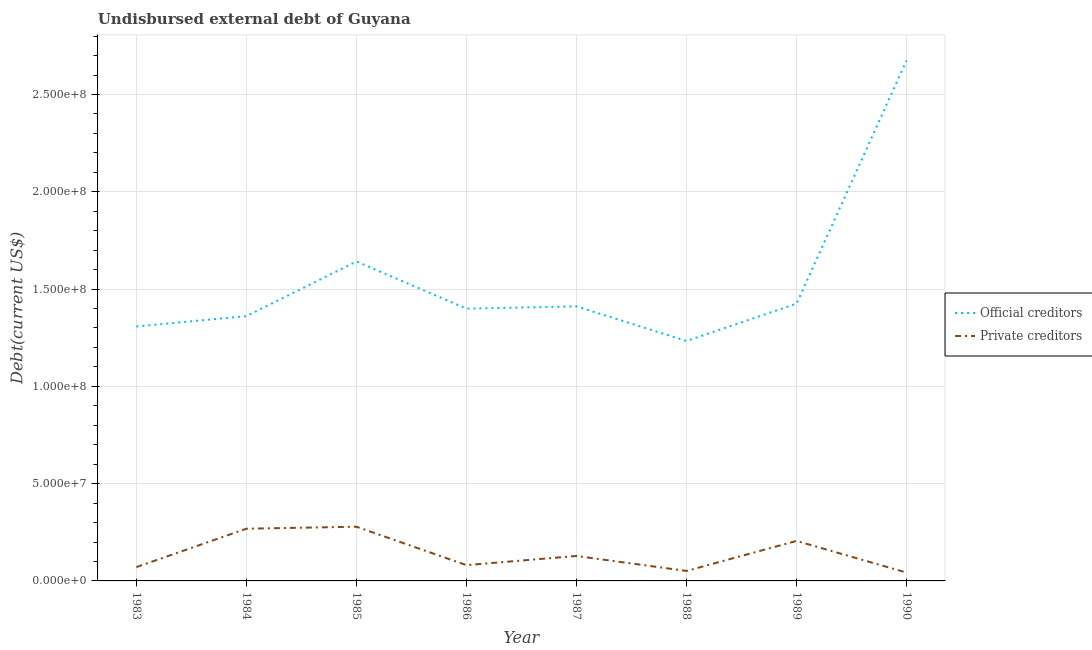How many different coloured lines are there?
Ensure brevity in your answer.  2. Is the number of lines equal to the number of legend labels?
Provide a short and direct response. Yes. What is the undisbursed external debt of private creditors in 1987?
Keep it short and to the point. 1.28e+07. Across all years, what is the maximum undisbursed external debt of official creditors?
Give a very brief answer. 2.67e+08. Across all years, what is the minimum undisbursed external debt of private creditors?
Offer a terse response. 4.30e+06. In which year was the undisbursed external debt of official creditors minimum?
Ensure brevity in your answer.  1988. What is the total undisbursed external debt of official creditors in the graph?
Give a very brief answer. 1.25e+09. What is the difference between the undisbursed external debt of official creditors in 1984 and that in 1990?
Make the answer very short. -1.31e+08. What is the difference between the undisbursed external debt of official creditors in 1987 and the undisbursed external debt of private creditors in 1984?
Make the answer very short. 1.14e+08. What is the average undisbursed external debt of official creditors per year?
Your response must be concise. 1.56e+08. In the year 1986, what is the difference between the undisbursed external debt of official creditors and undisbursed external debt of private creditors?
Your answer should be compact. 1.32e+08. In how many years, is the undisbursed external debt of official creditors greater than 110000000 US$?
Ensure brevity in your answer.  8. What is the ratio of the undisbursed external debt of private creditors in 1986 to that in 1988?
Provide a short and direct response. 1.58. Is the undisbursed external debt of private creditors in 1983 less than that in 1984?
Provide a succinct answer. Yes. Is the difference between the undisbursed external debt of official creditors in 1983 and 1984 greater than the difference between the undisbursed external debt of private creditors in 1983 and 1984?
Offer a very short reply. Yes. What is the difference between the highest and the second highest undisbursed external debt of private creditors?
Your answer should be compact. 1.03e+06. What is the difference between the highest and the lowest undisbursed external debt of official creditors?
Your response must be concise. 1.44e+08. Is the sum of the undisbursed external debt of official creditors in 1983 and 1986 greater than the maximum undisbursed external debt of private creditors across all years?
Your answer should be compact. Yes. Is the undisbursed external debt of private creditors strictly less than the undisbursed external debt of official creditors over the years?
Provide a short and direct response. Yes. How many lines are there?
Provide a short and direct response. 2. How many years are there in the graph?
Provide a succinct answer. 8. What is the difference between two consecutive major ticks on the Y-axis?
Provide a short and direct response. 5.00e+07. Does the graph contain any zero values?
Provide a short and direct response. No. Does the graph contain grids?
Ensure brevity in your answer.  Yes. What is the title of the graph?
Give a very brief answer. Undisbursed external debt of Guyana. Does "Public funds" appear as one of the legend labels in the graph?
Provide a succinct answer. No. What is the label or title of the X-axis?
Your response must be concise. Year. What is the label or title of the Y-axis?
Offer a very short reply. Debt(current US$). What is the Debt(current US$) in Official creditors in 1983?
Keep it short and to the point. 1.31e+08. What is the Debt(current US$) in Private creditors in 1983?
Your answer should be compact. 7.11e+06. What is the Debt(current US$) in Official creditors in 1984?
Your answer should be very brief. 1.36e+08. What is the Debt(current US$) of Private creditors in 1984?
Your response must be concise. 2.68e+07. What is the Debt(current US$) of Official creditors in 1985?
Offer a terse response. 1.64e+08. What is the Debt(current US$) of Private creditors in 1985?
Keep it short and to the point. 2.79e+07. What is the Debt(current US$) of Official creditors in 1986?
Provide a short and direct response. 1.40e+08. What is the Debt(current US$) in Private creditors in 1986?
Your answer should be very brief. 8.12e+06. What is the Debt(current US$) in Official creditors in 1987?
Provide a short and direct response. 1.41e+08. What is the Debt(current US$) of Private creditors in 1987?
Your answer should be very brief. 1.28e+07. What is the Debt(current US$) in Official creditors in 1988?
Offer a terse response. 1.23e+08. What is the Debt(current US$) in Private creditors in 1988?
Offer a very short reply. 5.13e+06. What is the Debt(current US$) of Official creditors in 1989?
Give a very brief answer. 1.42e+08. What is the Debt(current US$) in Private creditors in 1989?
Your answer should be very brief. 2.06e+07. What is the Debt(current US$) of Official creditors in 1990?
Provide a short and direct response. 2.67e+08. What is the Debt(current US$) in Private creditors in 1990?
Your answer should be compact. 4.30e+06. Across all years, what is the maximum Debt(current US$) of Official creditors?
Your response must be concise. 2.67e+08. Across all years, what is the maximum Debt(current US$) in Private creditors?
Keep it short and to the point. 2.79e+07. Across all years, what is the minimum Debt(current US$) of Official creditors?
Your answer should be compact. 1.23e+08. Across all years, what is the minimum Debt(current US$) in Private creditors?
Make the answer very short. 4.30e+06. What is the total Debt(current US$) in Official creditors in the graph?
Give a very brief answer. 1.25e+09. What is the total Debt(current US$) of Private creditors in the graph?
Provide a short and direct response. 1.13e+08. What is the difference between the Debt(current US$) in Official creditors in 1983 and that in 1984?
Offer a very short reply. -5.34e+06. What is the difference between the Debt(current US$) in Private creditors in 1983 and that in 1984?
Your response must be concise. -1.97e+07. What is the difference between the Debt(current US$) of Official creditors in 1983 and that in 1985?
Give a very brief answer. -3.34e+07. What is the difference between the Debt(current US$) in Private creditors in 1983 and that in 1985?
Give a very brief answer. -2.08e+07. What is the difference between the Debt(current US$) in Official creditors in 1983 and that in 1986?
Give a very brief answer. -9.17e+06. What is the difference between the Debt(current US$) of Private creditors in 1983 and that in 1986?
Provide a succinct answer. -1.01e+06. What is the difference between the Debt(current US$) in Official creditors in 1983 and that in 1987?
Make the answer very short. -1.03e+07. What is the difference between the Debt(current US$) of Private creditors in 1983 and that in 1987?
Your answer should be very brief. -5.71e+06. What is the difference between the Debt(current US$) in Official creditors in 1983 and that in 1988?
Offer a terse response. 7.45e+06. What is the difference between the Debt(current US$) of Private creditors in 1983 and that in 1988?
Ensure brevity in your answer.  1.98e+06. What is the difference between the Debt(current US$) in Official creditors in 1983 and that in 1989?
Make the answer very short. -1.17e+07. What is the difference between the Debt(current US$) of Private creditors in 1983 and that in 1989?
Make the answer very short. -1.34e+07. What is the difference between the Debt(current US$) of Official creditors in 1983 and that in 1990?
Your answer should be compact. -1.37e+08. What is the difference between the Debt(current US$) in Private creditors in 1983 and that in 1990?
Your response must be concise. 2.81e+06. What is the difference between the Debt(current US$) of Official creditors in 1984 and that in 1985?
Offer a terse response. -2.81e+07. What is the difference between the Debt(current US$) in Private creditors in 1984 and that in 1985?
Ensure brevity in your answer.  -1.03e+06. What is the difference between the Debt(current US$) in Official creditors in 1984 and that in 1986?
Your response must be concise. -3.84e+06. What is the difference between the Debt(current US$) in Private creditors in 1984 and that in 1986?
Your answer should be compact. 1.87e+07. What is the difference between the Debt(current US$) in Official creditors in 1984 and that in 1987?
Keep it short and to the point. -4.99e+06. What is the difference between the Debt(current US$) in Private creditors in 1984 and that in 1987?
Your answer should be very brief. 1.40e+07. What is the difference between the Debt(current US$) in Official creditors in 1984 and that in 1988?
Ensure brevity in your answer.  1.28e+07. What is the difference between the Debt(current US$) in Private creditors in 1984 and that in 1988?
Offer a very short reply. 2.17e+07. What is the difference between the Debt(current US$) of Official creditors in 1984 and that in 1989?
Give a very brief answer. -6.39e+06. What is the difference between the Debt(current US$) of Private creditors in 1984 and that in 1989?
Ensure brevity in your answer.  6.28e+06. What is the difference between the Debt(current US$) of Official creditors in 1984 and that in 1990?
Give a very brief answer. -1.31e+08. What is the difference between the Debt(current US$) of Private creditors in 1984 and that in 1990?
Your response must be concise. 2.25e+07. What is the difference between the Debt(current US$) of Official creditors in 1985 and that in 1986?
Ensure brevity in your answer.  2.42e+07. What is the difference between the Debt(current US$) of Private creditors in 1985 and that in 1986?
Provide a succinct answer. 1.97e+07. What is the difference between the Debt(current US$) of Official creditors in 1985 and that in 1987?
Give a very brief answer. 2.31e+07. What is the difference between the Debt(current US$) of Private creditors in 1985 and that in 1987?
Provide a succinct answer. 1.50e+07. What is the difference between the Debt(current US$) in Official creditors in 1985 and that in 1988?
Ensure brevity in your answer.  4.09e+07. What is the difference between the Debt(current US$) of Private creditors in 1985 and that in 1988?
Offer a terse response. 2.27e+07. What is the difference between the Debt(current US$) of Official creditors in 1985 and that in 1989?
Keep it short and to the point. 2.17e+07. What is the difference between the Debt(current US$) in Private creditors in 1985 and that in 1989?
Give a very brief answer. 7.31e+06. What is the difference between the Debt(current US$) of Official creditors in 1985 and that in 1990?
Provide a succinct answer. -1.03e+08. What is the difference between the Debt(current US$) of Private creditors in 1985 and that in 1990?
Give a very brief answer. 2.36e+07. What is the difference between the Debt(current US$) in Official creditors in 1986 and that in 1987?
Your answer should be compact. -1.16e+06. What is the difference between the Debt(current US$) in Private creditors in 1986 and that in 1987?
Provide a succinct answer. -4.70e+06. What is the difference between the Debt(current US$) of Official creditors in 1986 and that in 1988?
Keep it short and to the point. 1.66e+07. What is the difference between the Debt(current US$) in Private creditors in 1986 and that in 1988?
Give a very brief answer. 2.99e+06. What is the difference between the Debt(current US$) of Official creditors in 1986 and that in 1989?
Ensure brevity in your answer.  -2.56e+06. What is the difference between the Debt(current US$) in Private creditors in 1986 and that in 1989?
Provide a succinct answer. -1.24e+07. What is the difference between the Debt(current US$) in Official creditors in 1986 and that in 1990?
Give a very brief answer. -1.28e+08. What is the difference between the Debt(current US$) of Private creditors in 1986 and that in 1990?
Provide a short and direct response. 3.82e+06. What is the difference between the Debt(current US$) of Official creditors in 1987 and that in 1988?
Your response must be concise. 1.78e+07. What is the difference between the Debt(current US$) of Private creditors in 1987 and that in 1988?
Your answer should be compact. 7.69e+06. What is the difference between the Debt(current US$) of Official creditors in 1987 and that in 1989?
Your answer should be compact. -1.40e+06. What is the difference between the Debt(current US$) of Private creditors in 1987 and that in 1989?
Your response must be concise. -7.73e+06. What is the difference between the Debt(current US$) of Official creditors in 1987 and that in 1990?
Your response must be concise. -1.26e+08. What is the difference between the Debt(current US$) in Private creditors in 1987 and that in 1990?
Offer a terse response. 8.52e+06. What is the difference between the Debt(current US$) of Official creditors in 1988 and that in 1989?
Provide a succinct answer. -1.92e+07. What is the difference between the Debt(current US$) in Private creditors in 1988 and that in 1989?
Your answer should be compact. -1.54e+07. What is the difference between the Debt(current US$) of Official creditors in 1988 and that in 1990?
Your answer should be compact. -1.44e+08. What is the difference between the Debt(current US$) of Private creditors in 1988 and that in 1990?
Your answer should be very brief. 8.28e+05. What is the difference between the Debt(current US$) in Official creditors in 1989 and that in 1990?
Your answer should be compact. -1.25e+08. What is the difference between the Debt(current US$) of Private creditors in 1989 and that in 1990?
Your response must be concise. 1.62e+07. What is the difference between the Debt(current US$) in Official creditors in 1983 and the Debt(current US$) in Private creditors in 1984?
Provide a short and direct response. 1.04e+08. What is the difference between the Debt(current US$) in Official creditors in 1983 and the Debt(current US$) in Private creditors in 1985?
Provide a short and direct response. 1.03e+08. What is the difference between the Debt(current US$) of Official creditors in 1983 and the Debt(current US$) of Private creditors in 1986?
Your answer should be very brief. 1.23e+08. What is the difference between the Debt(current US$) in Official creditors in 1983 and the Debt(current US$) in Private creditors in 1987?
Your answer should be very brief. 1.18e+08. What is the difference between the Debt(current US$) in Official creditors in 1983 and the Debt(current US$) in Private creditors in 1988?
Ensure brevity in your answer.  1.26e+08. What is the difference between the Debt(current US$) in Official creditors in 1983 and the Debt(current US$) in Private creditors in 1989?
Ensure brevity in your answer.  1.10e+08. What is the difference between the Debt(current US$) in Official creditors in 1983 and the Debt(current US$) in Private creditors in 1990?
Provide a succinct answer. 1.26e+08. What is the difference between the Debt(current US$) of Official creditors in 1984 and the Debt(current US$) of Private creditors in 1985?
Provide a succinct answer. 1.08e+08. What is the difference between the Debt(current US$) of Official creditors in 1984 and the Debt(current US$) of Private creditors in 1986?
Offer a terse response. 1.28e+08. What is the difference between the Debt(current US$) of Official creditors in 1984 and the Debt(current US$) of Private creditors in 1987?
Provide a succinct answer. 1.23e+08. What is the difference between the Debt(current US$) in Official creditors in 1984 and the Debt(current US$) in Private creditors in 1988?
Give a very brief answer. 1.31e+08. What is the difference between the Debt(current US$) of Official creditors in 1984 and the Debt(current US$) of Private creditors in 1989?
Your response must be concise. 1.16e+08. What is the difference between the Debt(current US$) of Official creditors in 1984 and the Debt(current US$) of Private creditors in 1990?
Your answer should be very brief. 1.32e+08. What is the difference between the Debt(current US$) of Official creditors in 1985 and the Debt(current US$) of Private creditors in 1986?
Ensure brevity in your answer.  1.56e+08. What is the difference between the Debt(current US$) in Official creditors in 1985 and the Debt(current US$) in Private creditors in 1987?
Ensure brevity in your answer.  1.51e+08. What is the difference between the Debt(current US$) in Official creditors in 1985 and the Debt(current US$) in Private creditors in 1988?
Make the answer very short. 1.59e+08. What is the difference between the Debt(current US$) in Official creditors in 1985 and the Debt(current US$) in Private creditors in 1989?
Make the answer very short. 1.44e+08. What is the difference between the Debt(current US$) of Official creditors in 1985 and the Debt(current US$) of Private creditors in 1990?
Your answer should be compact. 1.60e+08. What is the difference between the Debt(current US$) in Official creditors in 1986 and the Debt(current US$) in Private creditors in 1987?
Your answer should be very brief. 1.27e+08. What is the difference between the Debt(current US$) in Official creditors in 1986 and the Debt(current US$) in Private creditors in 1988?
Ensure brevity in your answer.  1.35e+08. What is the difference between the Debt(current US$) of Official creditors in 1986 and the Debt(current US$) of Private creditors in 1989?
Your answer should be very brief. 1.19e+08. What is the difference between the Debt(current US$) in Official creditors in 1986 and the Debt(current US$) in Private creditors in 1990?
Keep it short and to the point. 1.36e+08. What is the difference between the Debt(current US$) of Official creditors in 1987 and the Debt(current US$) of Private creditors in 1988?
Make the answer very short. 1.36e+08. What is the difference between the Debt(current US$) in Official creditors in 1987 and the Debt(current US$) in Private creditors in 1989?
Keep it short and to the point. 1.21e+08. What is the difference between the Debt(current US$) of Official creditors in 1987 and the Debt(current US$) of Private creditors in 1990?
Offer a very short reply. 1.37e+08. What is the difference between the Debt(current US$) in Official creditors in 1988 and the Debt(current US$) in Private creditors in 1989?
Offer a terse response. 1.03e+08. What is the difference between the Debt(current US$) in Official creditors in 1988 and the Debt(current US$) in Private creditors in 1990?
Keep it short and to the point. 1.19e+08. What is the difference between the Debt(current US$) of Official creditors in 1989 and the Debt(current US$) of Private creditors in 1990?
Ensure brevity in your answer.  1.38e+08. What is the average Debt(current US$) of Official creditors per year?
Provide a succinct answer. 1.56e+08. What is the average Debt(current US$) in Private creditors per year?
Offer a very short reply. 1.41e+07. In the year 1983, what is the difference between the Debt(current US$) in Official creditors and Debt(current US$) in Private creditors?
Your response must be concise. 1.24e+08. In the year 1984, what is the difference between the Debt(current US$) in Official creditors and Debt(current US$) in Private creditors?
Ensure brevity in your answer.  1.09e+08. In the year 1985, what is the difference between the Debt(current US$) of Official creditors and Debt(current US$) of Private creditors?
Provide a succinct answer. 1.36e+08. In the year 1986, what is the difference between the Debt(current US$) in Official creditors and Debt(current US$) in Private creditors?
Your answer should be compact. 1.32e+08. In the year 1987, what is the difference between the Debt(current US$) in Official creditors and Debt(current US$) in Private creditors?
Ensure brevity in your answer.  1.28e+08. In the year 1988, what is the difference between the Debt(current US$) of Official creditors and Debt(current US$) of Private creditors?
Your response must be concise. 1.18e+08. In the year 1989, what is the difference between the Debt(current US$) of Official creditors and Debt(current US$) of Private creditors?
Provide a short and direct response. 1.22e+08. In the year 1990, what is the difference between the Debt(current US$) in Official creditors and Debt(current US$) in Private creditors?
Provide a short and direct response. 2.63e+08. What is the ratio of the Debt(current US$) in Official creditors in 1983 to that in 1984?
Your answer should be very brief. 0.96. What is the ratio of the Debt(current US$) of Private creditors in 1983 to that in 1984?
Give a very brief answer. 0.26. What is the ratio of the Debt(current US$) of Official creditors in 1983 to that in 1985?
Give a very brief answer. 0.8. What is the ratio of the Debt(current US$) in Private creditors in 1983 to that in 1985?
Provide a succinct answer. 0.26. What is the ratio of the Debt(current US$) in Official creditors in 1983 to that in 1986?
Keep it short and to the point. 0.93. What is the ratio of the Debt(current US$) in Private creditors in 1983 to that in 1986?
Your response must be concise. 0.88. What is the ratio of the Debt(current US$) of Official creditors in 1983 to that in 1987?
Ensure brevity in your answer.  0.93. What is the ratio of the Debt(current US$) of Private creditors in 1983 to that in 1987?
Offer a terse response. 0.55. What is the ratio of the Debt(current US$) of Official creditors in 1983 to that in 1988?
Offer a terse response. 1.06. What is the ratio of the Debt(current US$) of Private creditors in 1983 to that in 1988?
Make the answer very short. 1.39. What is the ratio of the Debt(current US$) of Official creditors in 1983 to that in 1989?
Ensure brevity in your answer.  0.92. What is the ratio of the Debt(current US$) of Private creditors in 1983 to that in 1989?
Your response must be concise. 0.35. What is the ratio of the Debt(current US$) in Official creditors in 1983 to that in 1990?
Your answer should be compact. 0.49. What is the ratio of the Debt(current US$) in Private creditors in 1983 to that in 1990?
Provide a succinct answer. 1.65. What is the ratio of the Debt(current US$) in Official creditors in 1984 to that in 1985?
Keep it short and to the point. 0.83. What is the ratio of the Debt(current US$) of Private creditors in 1984 to that in 1985?
Your answer should be compact. 0.96. What is the ratio of the Debt(current US$) of Official creditors in 1984 to that in 1986?
Keep it short and to the point. 0.97. What is the ratio of the Debt(current US$) in Private creditors in 1984 to that in 1986?
Your answer should be compact. 3.31. What is the ratio of the Debt(current US$) of Official creditors in 1984 to that in 1987?
Provide a succinct answer. 0.96. What is the ratio of the Debt(current US$) of Private creditors in 1984 to that in 1987?
Your response must be concise. 2.09. What is the ratio of the Debt(current US$) of Official creditors in 1984 to that in 1988?
Offer a very short reply. 1.1. What is the ratio of the Debt(current US$) in Private creditors in 1984 to that in 1988?
Your answer should be very brief. 5.23. What is the ratio of the Debt(current US$) in Official creditors in 1984 to that in 1989?
Ensure brevity in your answer.  0.96. What is the ratio of the Debt(current US$) in Private creditors in 1984 to that in 1989?
Give a very brief answer. 1.31. What is the ratio of the Debt(current US$) of Official creditors in 1984 to that in 1990?
Your answer should be very brief. 0.51. What is the ratio of the Debt(current US$) in Private creditors in 1984 to that in 1990?
Provide a short and direct response. 6.24. What is the ratio of the Debt(current US$) of Official creditors in 1985 to that in 1986?
Offer a very short reply. 1.17. What is the ratio of the Debt(current US$) of Private creditors in 1985 to that in 1986?
Offer a terse response. 3.43. What is the ratio of the Debt(current US$) in Official creditors in 1985 to that in 1987?
Your answer should be very brief. 1.16. What is the ratio of the Debt(current US$) in Private creditors in 1985 to that in 1987?
Your answer should be compact. 2.17. What is the ratio of the Debt(current US$) in Official creditors in 1985 to that in 1988?
Your answer should be very brief. 1.33. What is the ratio of the Debt(current US$) of Private creditors in 1985 to that in 1988?
Provide a short and direct response. 5.43. What is the ratio of the Debt(current US$) in Official creditors in 1985 to that in 1989?
Offer a terse response. 1.15. What is the ratio of the Debt(current US$) of Private creditors in 1985 to that in 1989?
Your answer should be very brief. 1.36. What is the ratio of the Debt(current US$) in Official creditors in 1985 to that in 1990?
Ensure brevity in your answer.  0.61. What is the ratio of the Debt(current US$) in Private creditors in 1985 to that in 1990?
Keep it short and to the point. 6.48. What is the ratio of the Debt(current US$) in Official creditors in 1986 to that in 1987?
Provide a succinct answer. 0.99. What is the ratio of the Debt(current US$) in Private creditors in 1986 to that in 1987?
Offer a very short reply. 0.63. What is the ratio of the Debt(current US$) of Official creditors in 1986 to that in 1988?
Offer a terse response. 1.13. What is the ratio of the Debt(current US$) in Private creditors in 1986 to that in 1988?
Make the answer very short. 1.58. What is the ratio of the Debt(current US$) of Official creditors in 1986 to that in 1989?
Give a very brief answer. 0.98. What is the ratio of the Debt(current US$) in Private creditors in 1986 to that in 1989?
Ensure brevity in your answer.  0.39. What is the ratio of the Debt(current US$) in Official creditors in 1986 to that in 1990?
Keep it short and to the point. 0.52. What is the ratio of the Debt(current US$) in Private creditors in 1986 to that in 1990?
Give a very brief answer. 1.89. What is the ratio of the Debt(current US$) in Official creditors in 1987 to that in 1988?
Make the answer very short. 1.14. What is the ratio of the Debt(current US$) of Private creditors in 1987 to that in 1988?
Offer a very short reply. 2.5. What is the ratio of the Debt(current US$) in Official creditors in 1987 to that in 1989?
Provide a succinct answer. 0.99. What is the ratio of the Debt(current US$) in Private creditors in 1987 to that in 1989?
Provide a succinct answer. 0.62. What is the ratio of the Debt(current US$) of Official creditors in 1987 to that in 1990?
Provide a short and direct response. 0.53. What is the ratio of the Debt(current US$) of Private creditors in 1987 to that in 1990?
Offer a terse response. 2.98. What is the ratio of the Debt(current US$) of Official creditors in 1988 to that in 1989?
Ensure brevity in your answer.  0.87. What is the ratio of the Debt(current US$) in Private creditors in 1988 to that in 1989?
Your response must be concise. 0.25. What is the ratio of the Debt(current US$) of Official creditors in 1988 to that in 1990?
Keep it short and to the point. 0.46. What is the ratio of the Debt(current US$) in Private creditors in 1988 to that in 1990?
Your answer should be compact. 1.19. What is the ratio of the Debt(current US$) in Official creditors in 1989 to that in 1990?
Give a very brief answer. 0.53. What is the ratio of the Debt(current US$) in Private creditors in 1989 to that in 1990?
Your answer should be compact. 4.78. What is the difference between the highest and the second highest Debt(current US$) of Official creditors?
Ensure brevity in your answer.  1.03e+08. What is the difference between the highest and the second highest Debt(current US$) in Private creditors?
Offer a very short reply. 1.03e+06. What is the difference between the highest and the lowest Debt(current US$) in Official creditors?
Your answer should be compact. 1.44e+08. What is the difference between the highest and the lowest Debt(current US$) of Private creditors?
Offer a terse response. 2.36e+07. 